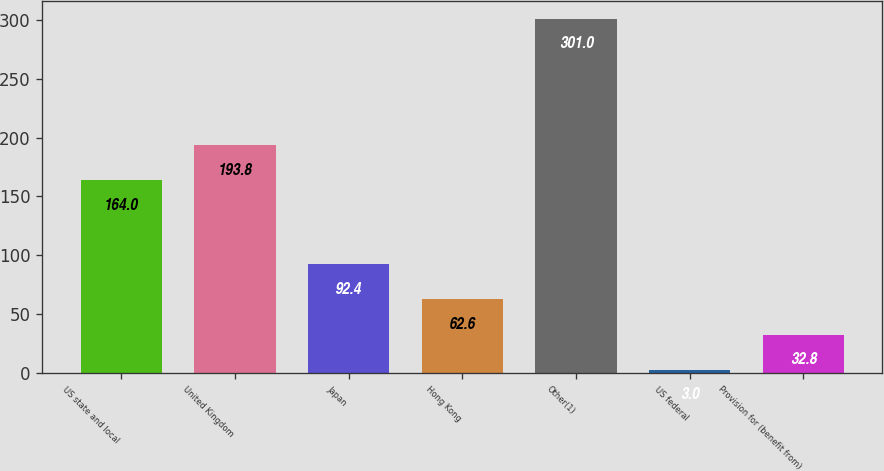Convert chart. <chart><loc_0><loc_0><loc_500><loc_500><bar_chart><fcel>US state and local<fcel>United Kingdom<fcel>Japan<fcel>Hong Kong<fcel>Other(1)<fcel>US federal<fcel>Provision for (benefit from)<nl><fcel>164<fcel>193.8<fcel>92.4<fcel>62.6<fcel>301<fcel>3<fcel>32.8<nl></chart> 